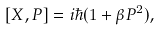Convert formula to latex. <formula><loc_0><loc_0><loc_500><loc_500>[ X , P ] = i \hbar { ( } 1 + \beta P ^ { 2 } ) ,</formula> 